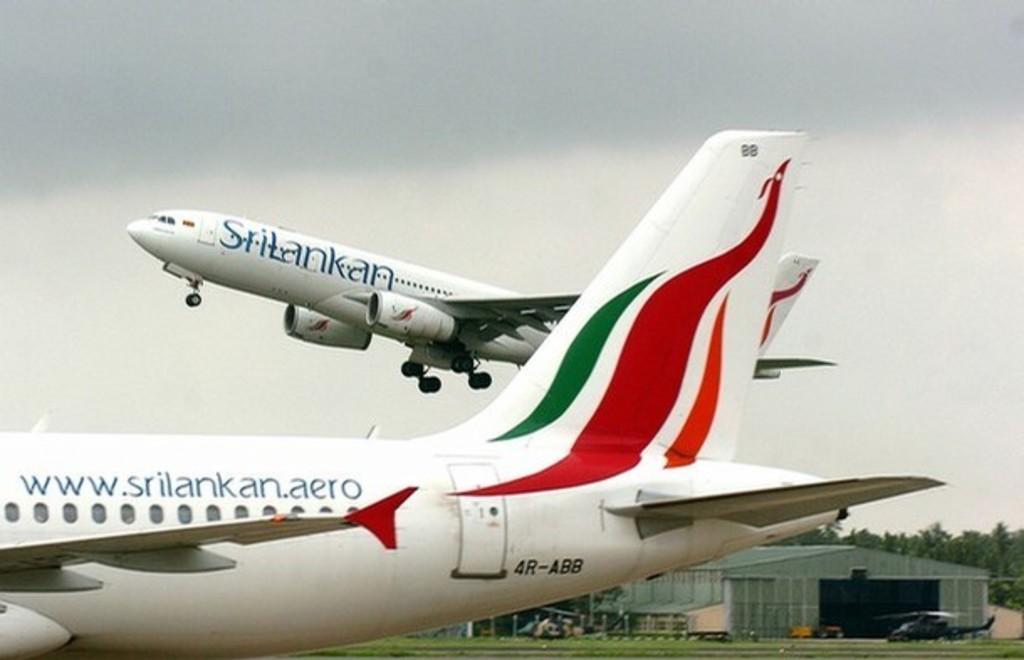What air libe is this?
Ensure brevity in your answer.  Srilankan. What is the near aircraft's identification code?
Give a very brief answer. 4r-abb. 